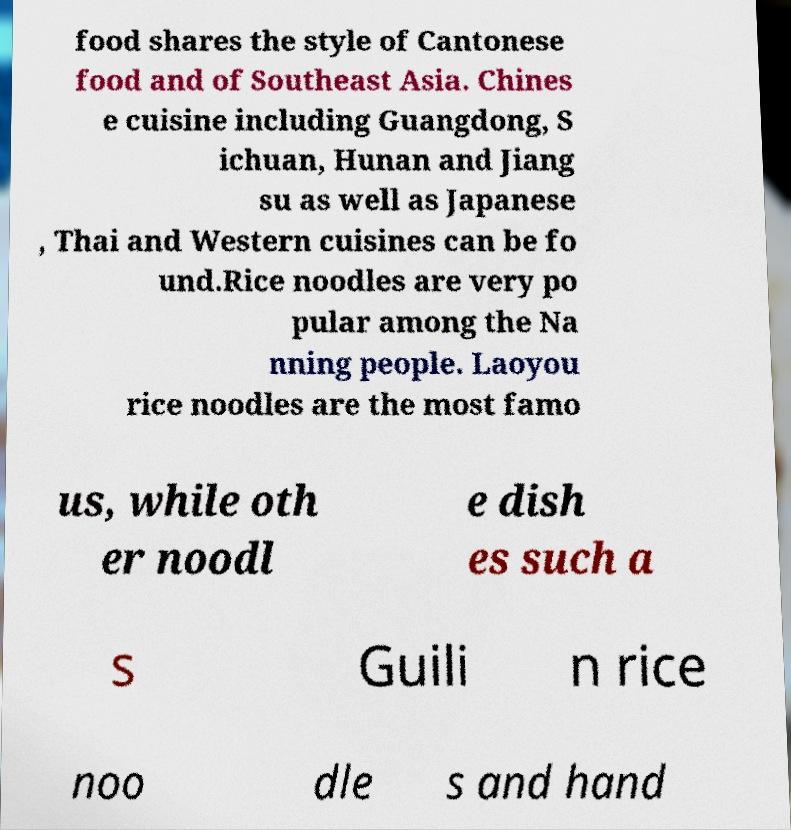I need the written content from this picture converted into text. Can you do that? food shares the style of Cantonese food and of Southeast Asia. Chines e cuisine including Guangdong, S ichuan, Hunan and Jiang su as well as Japanese , Thai and Western cuisines can be fo und.Rice noodles are very po pular among the Na nning people. Laoyou rice noodles are the most famo us, while oth er noodl e dish es such a s Guili n rice noo dle s and hand 